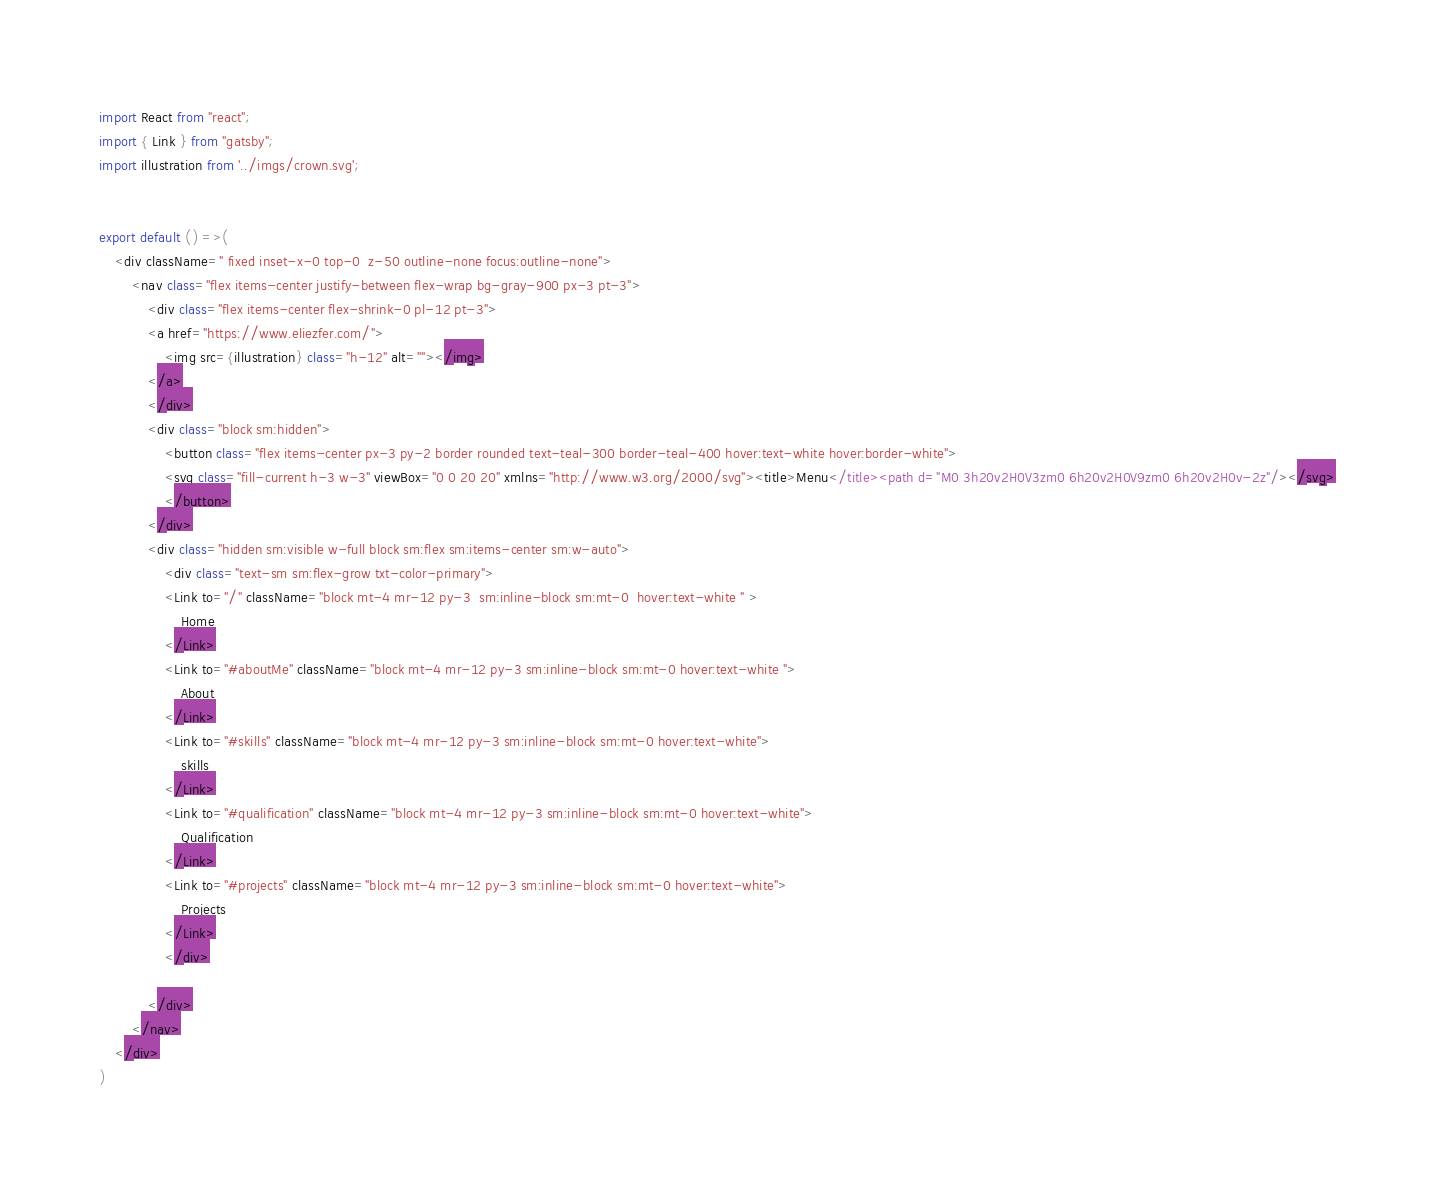Convert code to text. <code><loc_0><loc_0><loc_500><loc_500><_JavaScript_>import React from "react";
import { Link } from "gatsby";
import illustration from '../imgs/crown.svg';


export default () =>(
    <div className=" fixed inset-x-0 top-0  z-50 outline-none focus:outline-none">
        <nav class="flex items-center justify-between flex-wrap bg-gray-900 px-3 pt-3">
            <div class="flex items-center flex-shrink-0 pl-12 pt-3">
            <a href="https://www.eliezfer.com/">
                <img src={illustration} class="h-12" alt=""></img>
            </a>
            </div>
            <div class="block sm:hidden">
                <button class="flex items-center px-3 py-2 border rounded text-teal-300 border-teal-400 hover:text-white hover:border-white">
                <svg class="fill-current h-3 w-3" viewBox="0 0 20 20" xmlns="http://www.w3.org/2000/svg"><title>Menu</title><path d="M0 3h20v2H0V3zm0 6h20v2H0V9zm0 6h20v2H0v-2z"/></svg>
                </button>
            </div>
            <div class="hidden sm:visible w-full block sm:flex sm:items-center sm:w-auto">
                <div class="text-sm sm:flex-grow txt-color-primary">
                <Link to="/" className="block mt-4 mr-12 py-3  sm:inline-block sm:mt-0  hover:text-white " >
                    Home
                </Link>
                <Link to="#aboutMe" className="block mt-4 mr-12 py-3 sm:inline-block sm:mt-0 hover:text-white ">
                    About
                </Link>
                <Link to="#skills" className="block mt-4 mr-12 py-3 sm:inline-block sm:mt-0 hover:text-white">
                    skills
                </Link>
                <Link to="#qualification" className="block mt-4 mr-12 py-3 sm:inline-block sm:mt-0 hover:text-white">
                    Qualification
                </Link>
                <Link to="#projects" className="block mt-4 mr-12 py-3 sm:inline-block sm:mt-0 hover:text-white">
                    Projects
                </Link>
                </div>
                
            </div>
        </nav>
    </div>
)</code> 